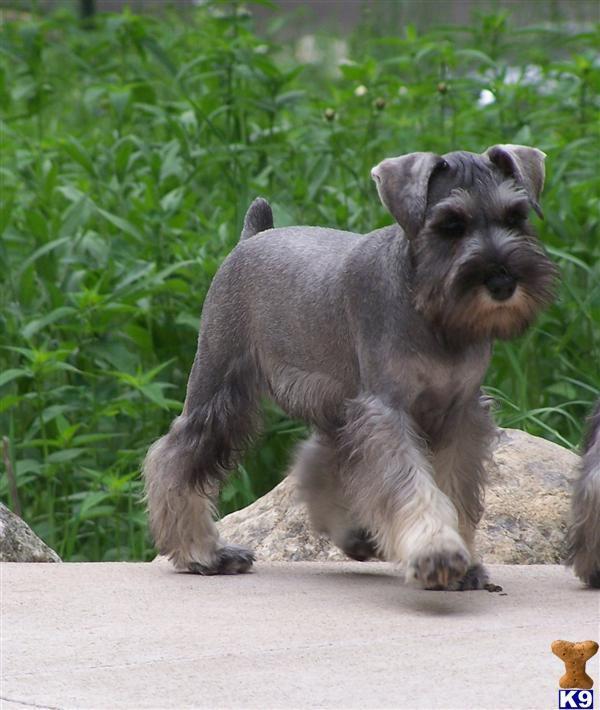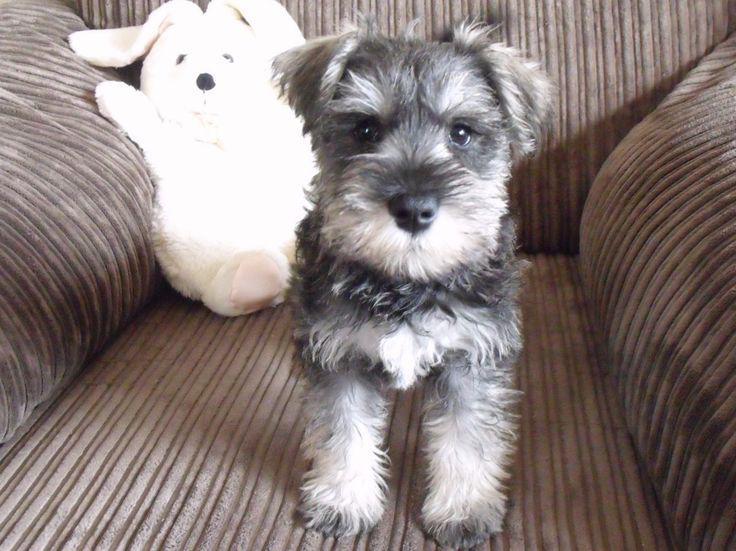The first image is the image on the left, the second image is the image on the right. Analyze the images presented: Is the assertion "An image shows a schnauzer with bright green foliage." valid? Answer yes or no. Yes. The first image is the image on the left, the second image is the image on the right. For the images shown, is this caption "Greenery is visible in an image of a schnauzer." true? Answer yes or no. Yes. The first image is the image on the left, the second image is the image on the right. For the images shown, is this caption "The dog in the left image is facing towards the right." true? Answer yes or no. Yes. The first image is the image on the left, the second image is the image on the right. Analyze the images presented: Is the assertion "AT least one dog is wearing a collar." valid? Answer yes or no. No. 